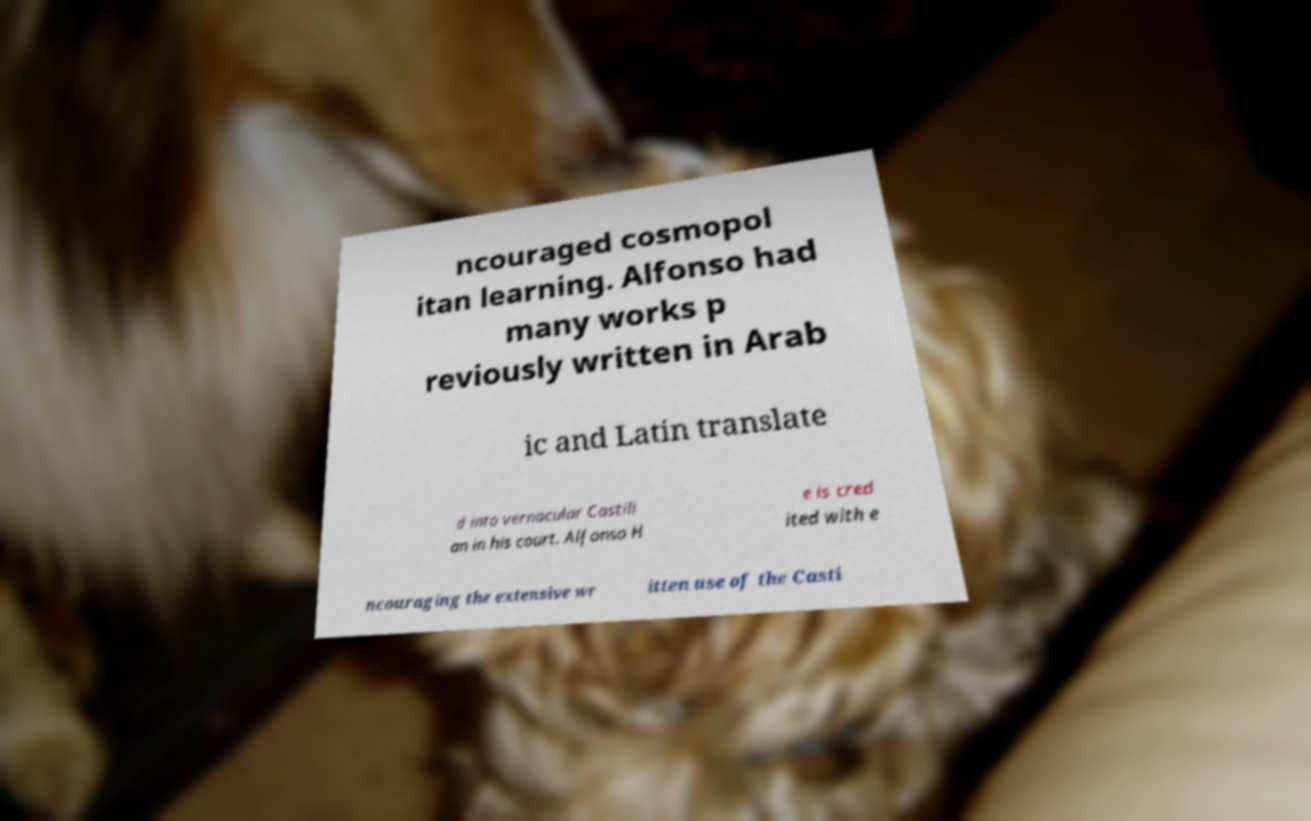Could you assist in decoding the text presented in this image and type it out clearly? ncouraged cosmopol itan learning. Alfonso had many works p reviously written in Arab ic and Latin translate d into vernacular Castili an in his court. Alfonso H e is cred ited with e ncouraging the extensive wr itten use of the Casti 